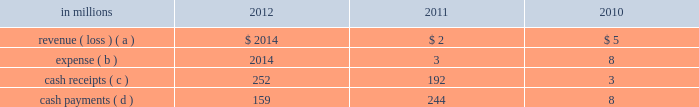Determined that it was the primary beneficiary of the 2001 financing entities and thus consolidated the entities effective march 16 , 2011 .
Effective april 30 , 2011 , international paper liquidated its interest in the 2001 financing entities .
Activity between the company and the 2002 financ- ing entities was as follows: .
( a ) the revenue is included in equity earnings ( loss ) , net of tax in the accompanying consolidated statement of operations .
( b ) the expense is included in interest expense , net in the accom- panying consolidated statement of operations .
( c ) the cash receipts are equity distributions from the 2002 financ- ing entities to international paper and cash receipts from the maturity of the 2002 monetized notes .
( d ) the cash payments include both interest and principal on the associated debt obligations .
On may 31 , 2011 , the third-party equity holder of the 2002 financing entities retired its class a interest in the entities for $ 51 million .
As a result of the retire- ment , effective may 31 , 2011 , international paper owned 100% ( 100 % ) of the 2002 financing entities .
Based on an analysis performed by the company after the retirement , under guidance that considers the poten- tial magnitude of the variability in the structure and which party has controlling financial interest , international paper determined that it was the pri- mary beneficiary of the 2002 financing entities and thus consolidated the entities effective may 31 , 2011 .
During the year ended december 31 , 2011 approx- imately $ 191 million of the 2002 monetized notes matured .
Outstanding debt related to these entities of $ 158 million is included in floating rate notes due 2011 2013 2017 in the summary of long-term debt in note 12 at december 31 , 2011 .
As of may 31 , 2012 , this debt had been repaid .
During the year ended december 31 , 2012 , $ 252 mil- lion of the 2002 monetized notes matured .
As of result of these maturities , accounts and notes receivable decreased $ 252 million and notes payable and current maturities of long-term debt decreased $ 158 million .
Deferred tax liabilities associated with the 2002 forestland installment sales decreased $ 67 million .
Effective june 1 , 2012 , international paper liquidated its interest in the 2002 financing entities .
The use of the above entities facilitated the mone- tization of the credit enhanced timber and mone- tized notes in a cost effective manner by increasing the borrowing capacity and lowering the interest rate while continuing to preserve the tax deferral that resulted from the forestlands installment sales and the offset accounting treatment described above .
In connection with the acquisition of temple-inland in february 2012 , two special purpose entities became wholly-owned subsidiaries of international paper .
In october 2007 , temple-inland sold 1.55 million acres of timberlands for $ 2.38 billion .
The total con- sideration consisted almost entirely of notes due in 2027 issued by the buyer of the timberlands , which temple-inland contributed to two wholly-owned , bankruptcy-remote special purpose entities .
The notes are shown in financial assets of special pur- pose entities in the accompanying consolidated balance sheet and are supported by $ 2.38 billion of irrevocable letters of credit issued by three banks , which are required to maintain minimum credit rat- ings on their long-term debt .
In the third quarter of 2012 , international paper completed is preliminary analysis of the acquisition date fair value of the notes and determined it to be $ 2.09 billion .
As a result of this analysis , financial assets of special purposed entities decreased by $ 292 million and goodwill increased by the same amount .
As of december 31 , 2012 , the fair value of the notes was $ 2.21 billion .
In december 2007 , temple-inland 2019s two wholly- owned special purpose entities borrowed $ 2.14 bil- lion shown in nonrecourse financial liabilities of special purpose entities in the accompanying con- solidated balance sheet .
The loans are repayable in 2027 and are secured only by the $ 2.38 billion of notes and the irrevocable letters of credit securing the notes and are nonrecourse to the company .
The loan agreements provide that if a credit rating of any of the banks issuing the letters of credit is down- graded below the specified threshold , the letters of credit issued by that bank must be replaced within 30 days with letters of credit from another qualifying financial institution .
In the third quarter of 2012 , international paper completed its preliminary analy- sis of the acquisition date fair value of the borrow- ings and determined it to be $ 2.03 billion .
As a result of this analysis , nonrecourse financial liabilities of special purpose entities decreased by $ 110 million and goodwill decreased by the same amount .
As of december 31 , 2012 , the fair value of this debt was $ 2.12 billion .
The buyer of the temple-inland timberland issued the $ 2.38 billion in notes from its wholly-owned , bankruptcy-remote special purpose entities .
The buyer 2019s special purpose entities held the timberlands from the transaction date until november 2008 , at which time the timberlands were transferred out of the buyer 2019s special purpose entities .
Due to the transfer of the timberlands , temple-inland evaluated the buyer 2019s special purpose entities and determined that they were variable interest entities and that temple-inland was the primary beneficiary .
As a result , in 2008 , temple-inland .
What was the change in the fair value of the debt acquisition date fair value of the borrow- ings? 
Computations: (2.12 - 2.03)
Answer: 0.09. 